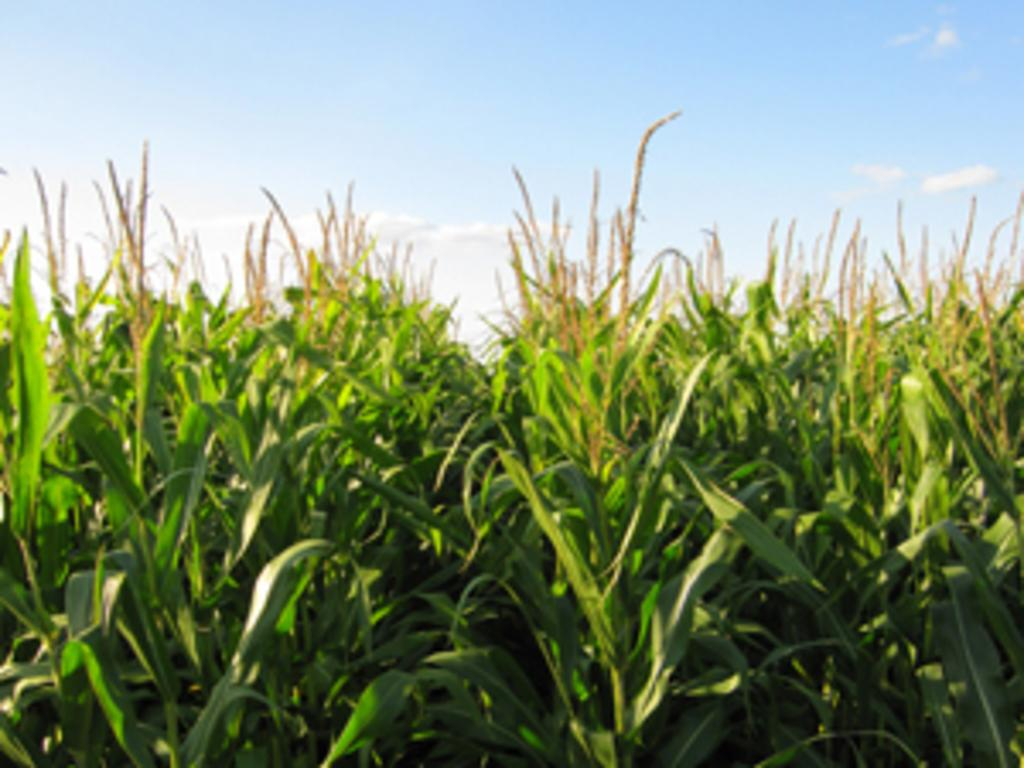What is the main subject of the image? The main subject of the image is a maize field. What can be seen in the sky in the background of the image? There are clouds in the sky in the background of the image. How many dogs are present in the image? There are no dogs present in the image; it features a maize field and clouds in the sky. What type of error can be seen in the image? There is no error present in the image; it is a clear photograph of a maize field and clouds in the sky. 